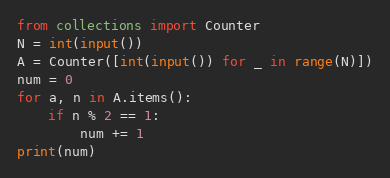<code> <loc_0><loc_0><loc_500><loc_500><_Python_>from collections import Counter
N = int(input())
A = Counter([int(input()) for _ in range(N)])
num = 0
for a, n in A.items():
    if n % 2 == 1:
        num += 1
print(num)
</code> 